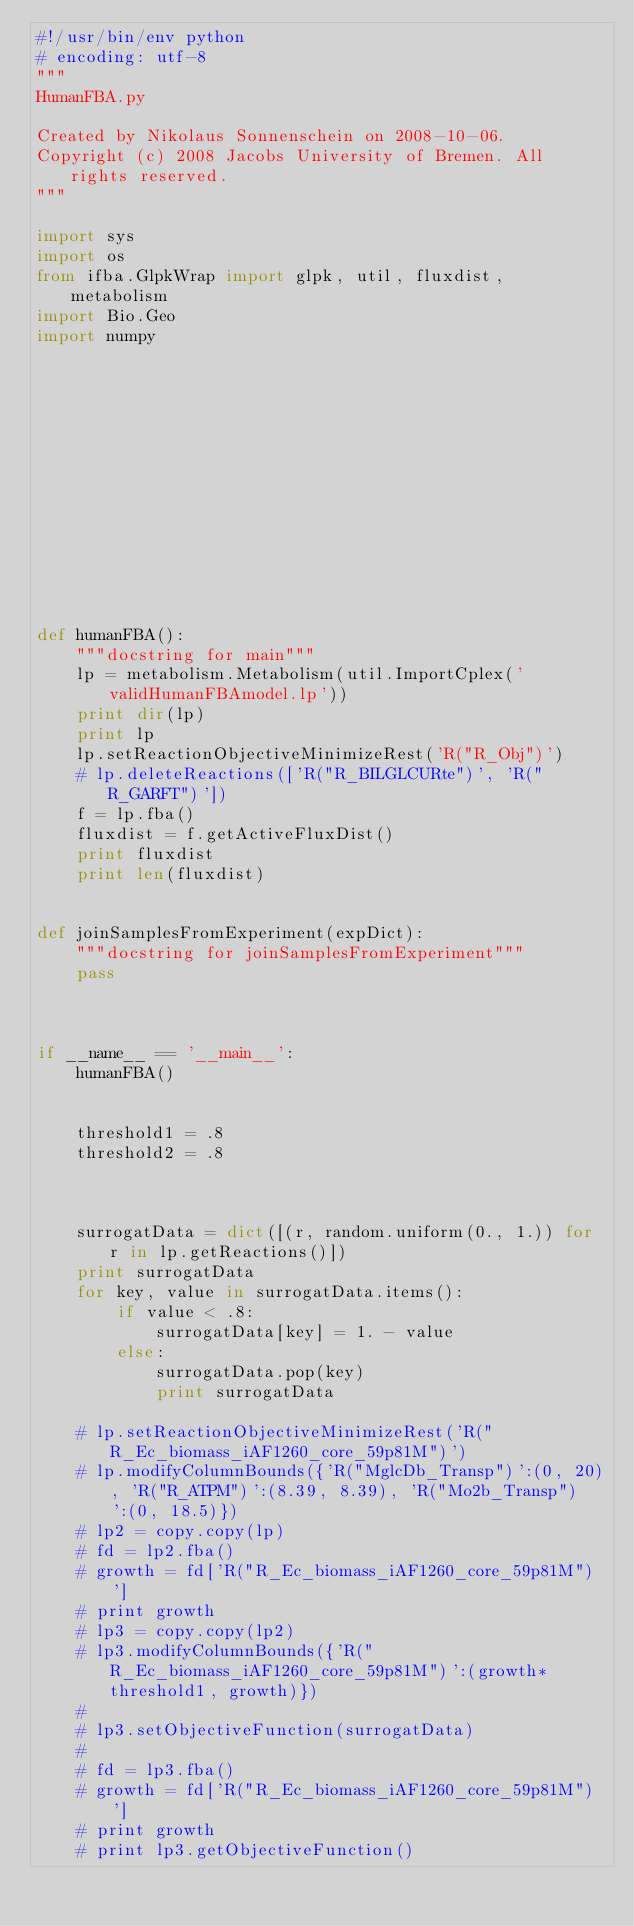<code> <loc_0><loc_0><loc_500><loc_500><_Python_>#!/usr/bin/env python
# encoding: utf-8
"""
HumanFBA.py

Created by Nikolaus Sonnenschein on 2008-10-06.
Copyright (c) 2008 Jacobs University of Bremen. All rights reserved.
"""

import sys
import os
from ifba.GlpkWrap import glpk, util, fluxdist, metabolism
import Bio.Geo
import numpy


        











def humanFBA():
    """docstring for main"""
    lp = metabolism.Metabolism(util.ImportCplex('validHumanFBAmodel.lp'))
    print dir(lp)
    print lp
    lp.setReactionObjectiveMinimizeRest('R("R_Obj")')
    # lp.deleteReactions(['R("R_BILGLCURte")', 'R("R_GARFT")'])
    f = lp.fba()
    fluxdist = f.getActiveFluxDist()
    print fluxdist
    print len(fluxdist)
    

def joinSamplesFromExperiment(expDict):
    """docstring for joinSamplesFromExperiment"""
    pass
    
    
    
if __name__ == '__main__':
    humanFBA()


    threshold1 = .8
    threshold2 = .8



    surrogatData = dict([(r, random.uniform(0., 1.)) for r in lp.getReactions()])
    print surrogatData
    for key, value in surrogatData.items():
        if value < .8:
            surrogatData[key] = 1. - value
        else:
            surrogatData.pop(key)
            print surrogatData

    # lp.setReactionObjectiveMinimizeRest('R("R_Ec_biomass_iAF1260_core_59p81M")')
    # lp.modifyColumnBounds({'R("MglcDb_Transp")':(0, 20), 'R("R_ATPM")':(8.39, 8.39), 'R("Mo2b_Transp")':(0, 18.5)})
    # lp2 = copy.copy(lp)
    # fd = lp2.fba()
    # growth = fd['R("R_Ec_biomass_iAF1260_core_59p81M")']
    # print growth
    # lp3 = copy.copy(lp2)
    # lp3.modifyColumnBounds({'R("R_Ec_biomass_iAF1260_core_59p81M")':(growth*threshold1, growth)})
    # 
    # lp3.setObjectiveFunction(surrogatData)
    # 
    # fd = lp3.fba()
    # growth = fd['R("R_Ec_biomass_iAF1260_core_59p81M")']
    # print growth
    # print lp3.getObjectiveFunction()
</code> 